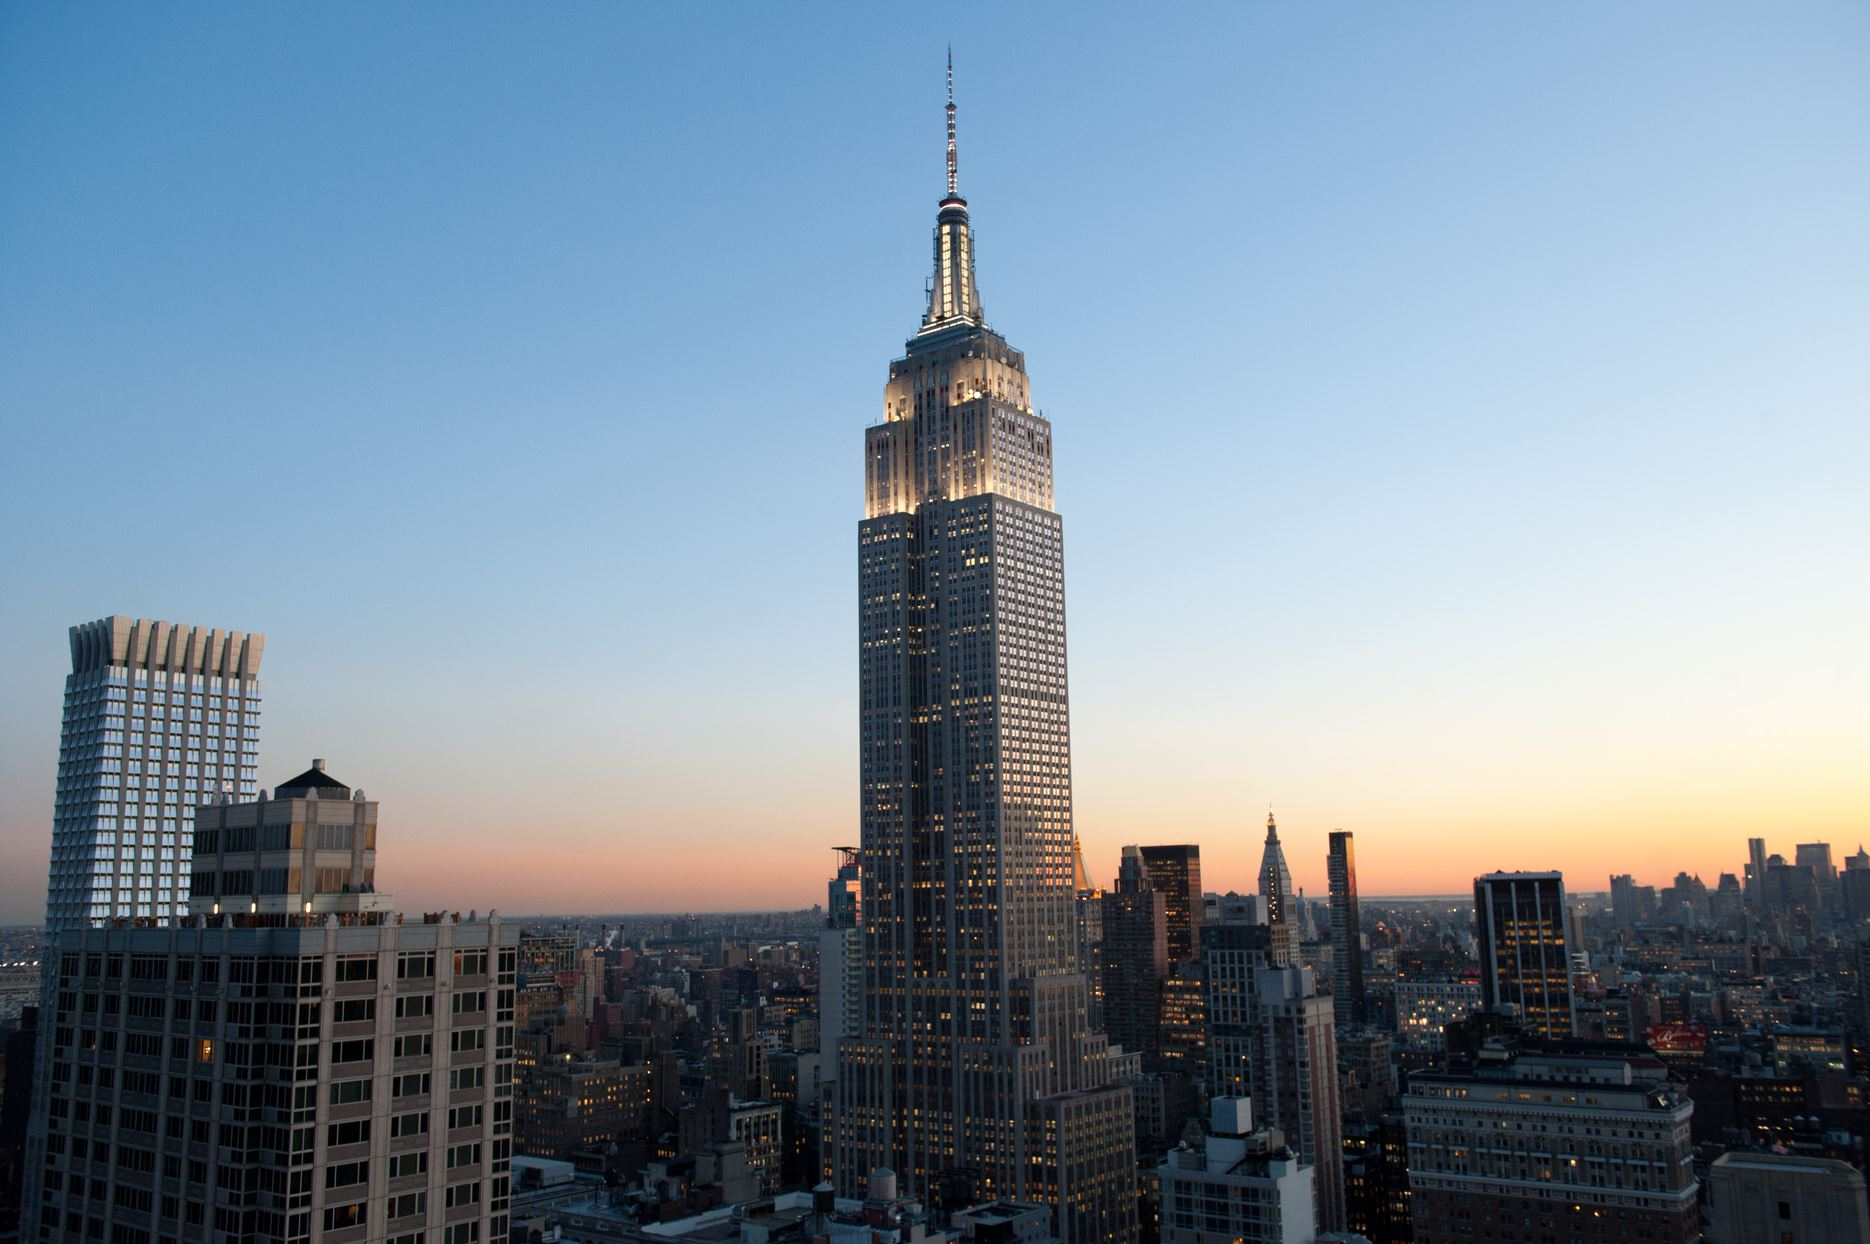How does the lighting on the Empire State Building affect its appearance in this image? The lighting on the Empire State Building greatly enhances its architectural details and overall prominence. The bright white lights outlining the building's structure against the twilight sky not only highlight its impressive height and art deco styling but also create a focal point for the viewer, making it stand out amid the surrounding cityscape. What can you tell about the role of this building in the context of New York City? The Empire State Building is not just an architectural marvel but also a cultural symbol of New York City. Standing at 1,454 feet, it was once the tallest building in the world and has been featured in numerous films, photographs, and literature. It represents the ambition and innovation of the city, attracting millions of visitors each year who come to admire its view from the observation decks and its historical significance. 